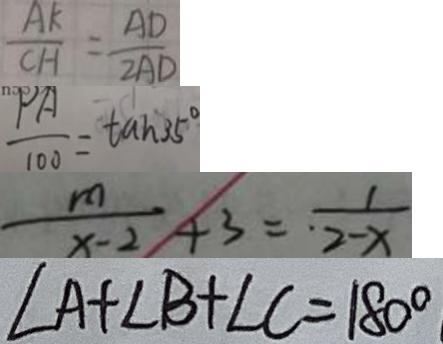Convert formula to latex. <formula><loc_0><loc_0><loc_500><loc_500>\frac { A K } { C H } = \frac { A D } { 2 A D } 
 \frac { P A } { 1 0 0 } = \tan 3 5 ^ { \circ } 
 \frac { m } { x - 2 } + 3 = \frac { 1 } { 2 - x } 
 \angle A + \angle B + \angle C = 1 8 0 ^ { \circ }</formula> 